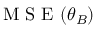Convert formula to latex. <formula><loc_0><loc_0><loc_500><loc_500>M S E ( \theta _ { B } )</formula> 